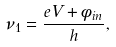Convert formula to latex. <formula><loc_0><loc_0><loc_500><loc_500>\nu _ { 1 } = \frac { e V + \phi _ { i n } } { h } ,</formula> 